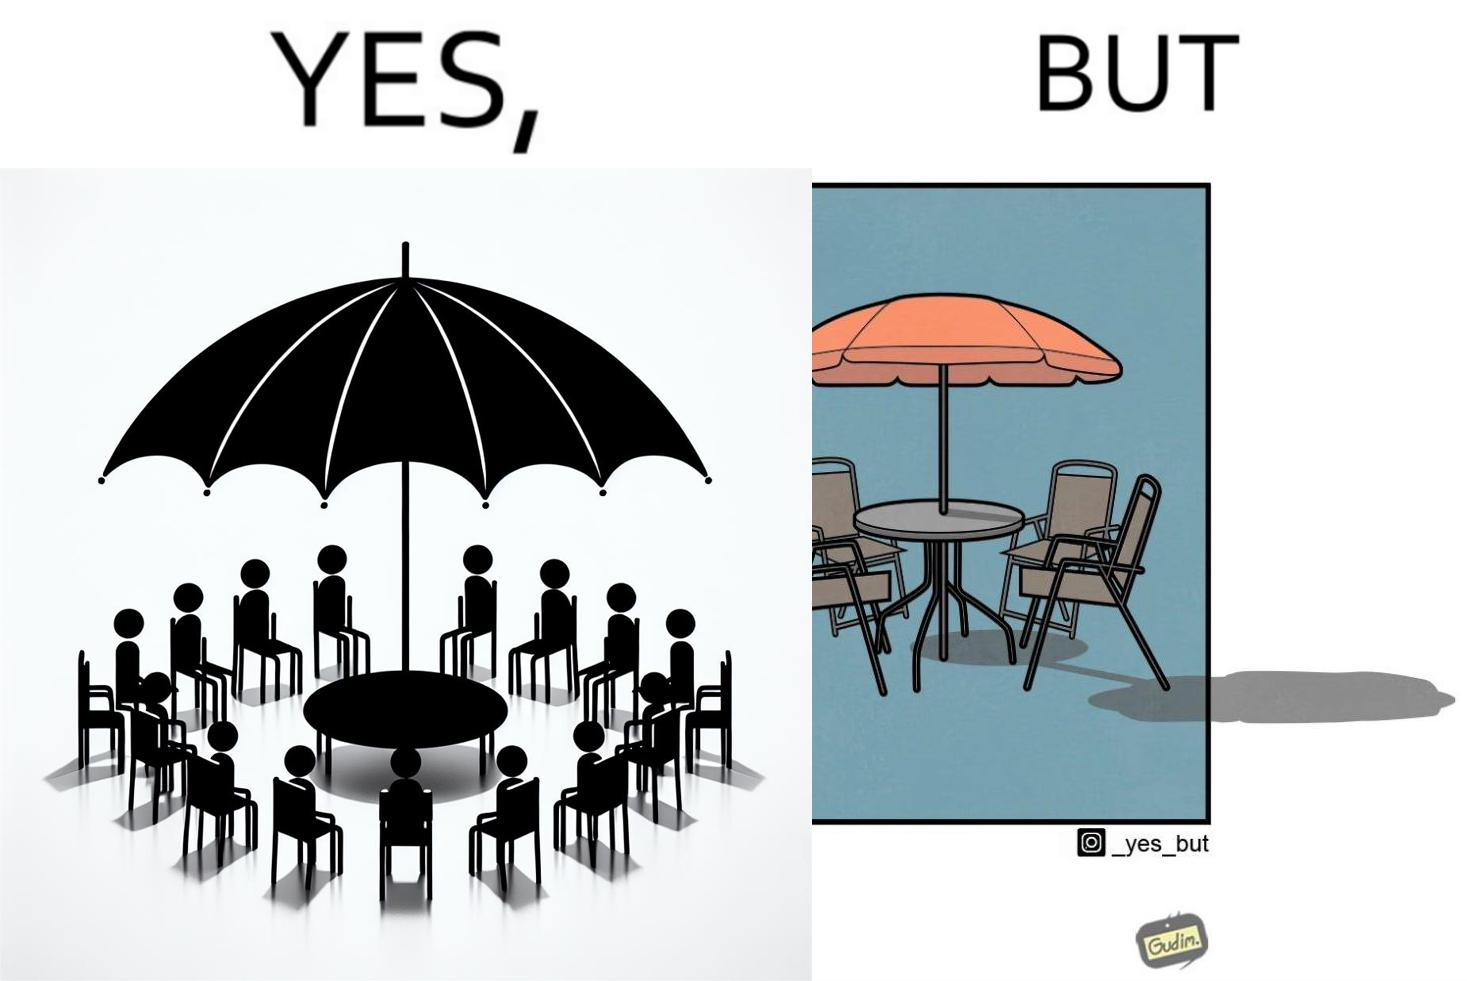Explain the humor or irony in this image. The image is ironical, as the umbrella is meant to provide shadow in the area where the chairs are present, but due to the orientation of the rays of the sun, all the chairs are in sunlight, and the umbrella is of no use in this situation. 